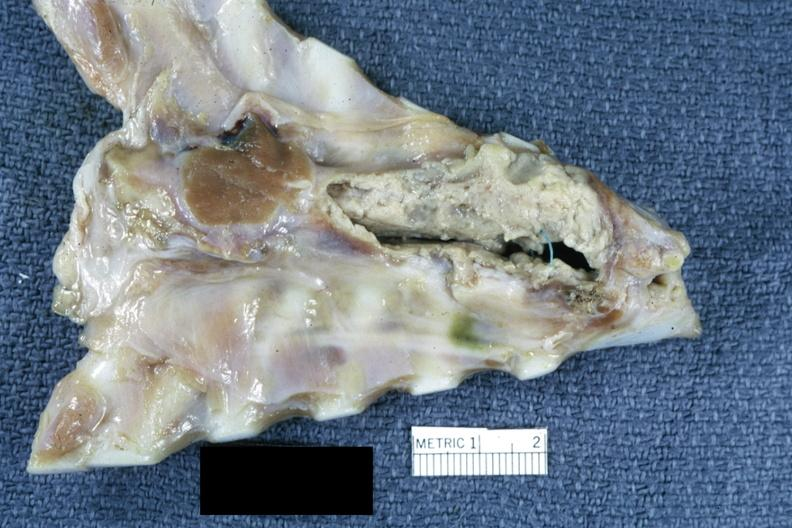what does this image show?
Answer the question using a single word or phrase. Breast plate showing substernal abscess and sutures of sternum splitting incision good illustration of a difficult to illustrate lesion 